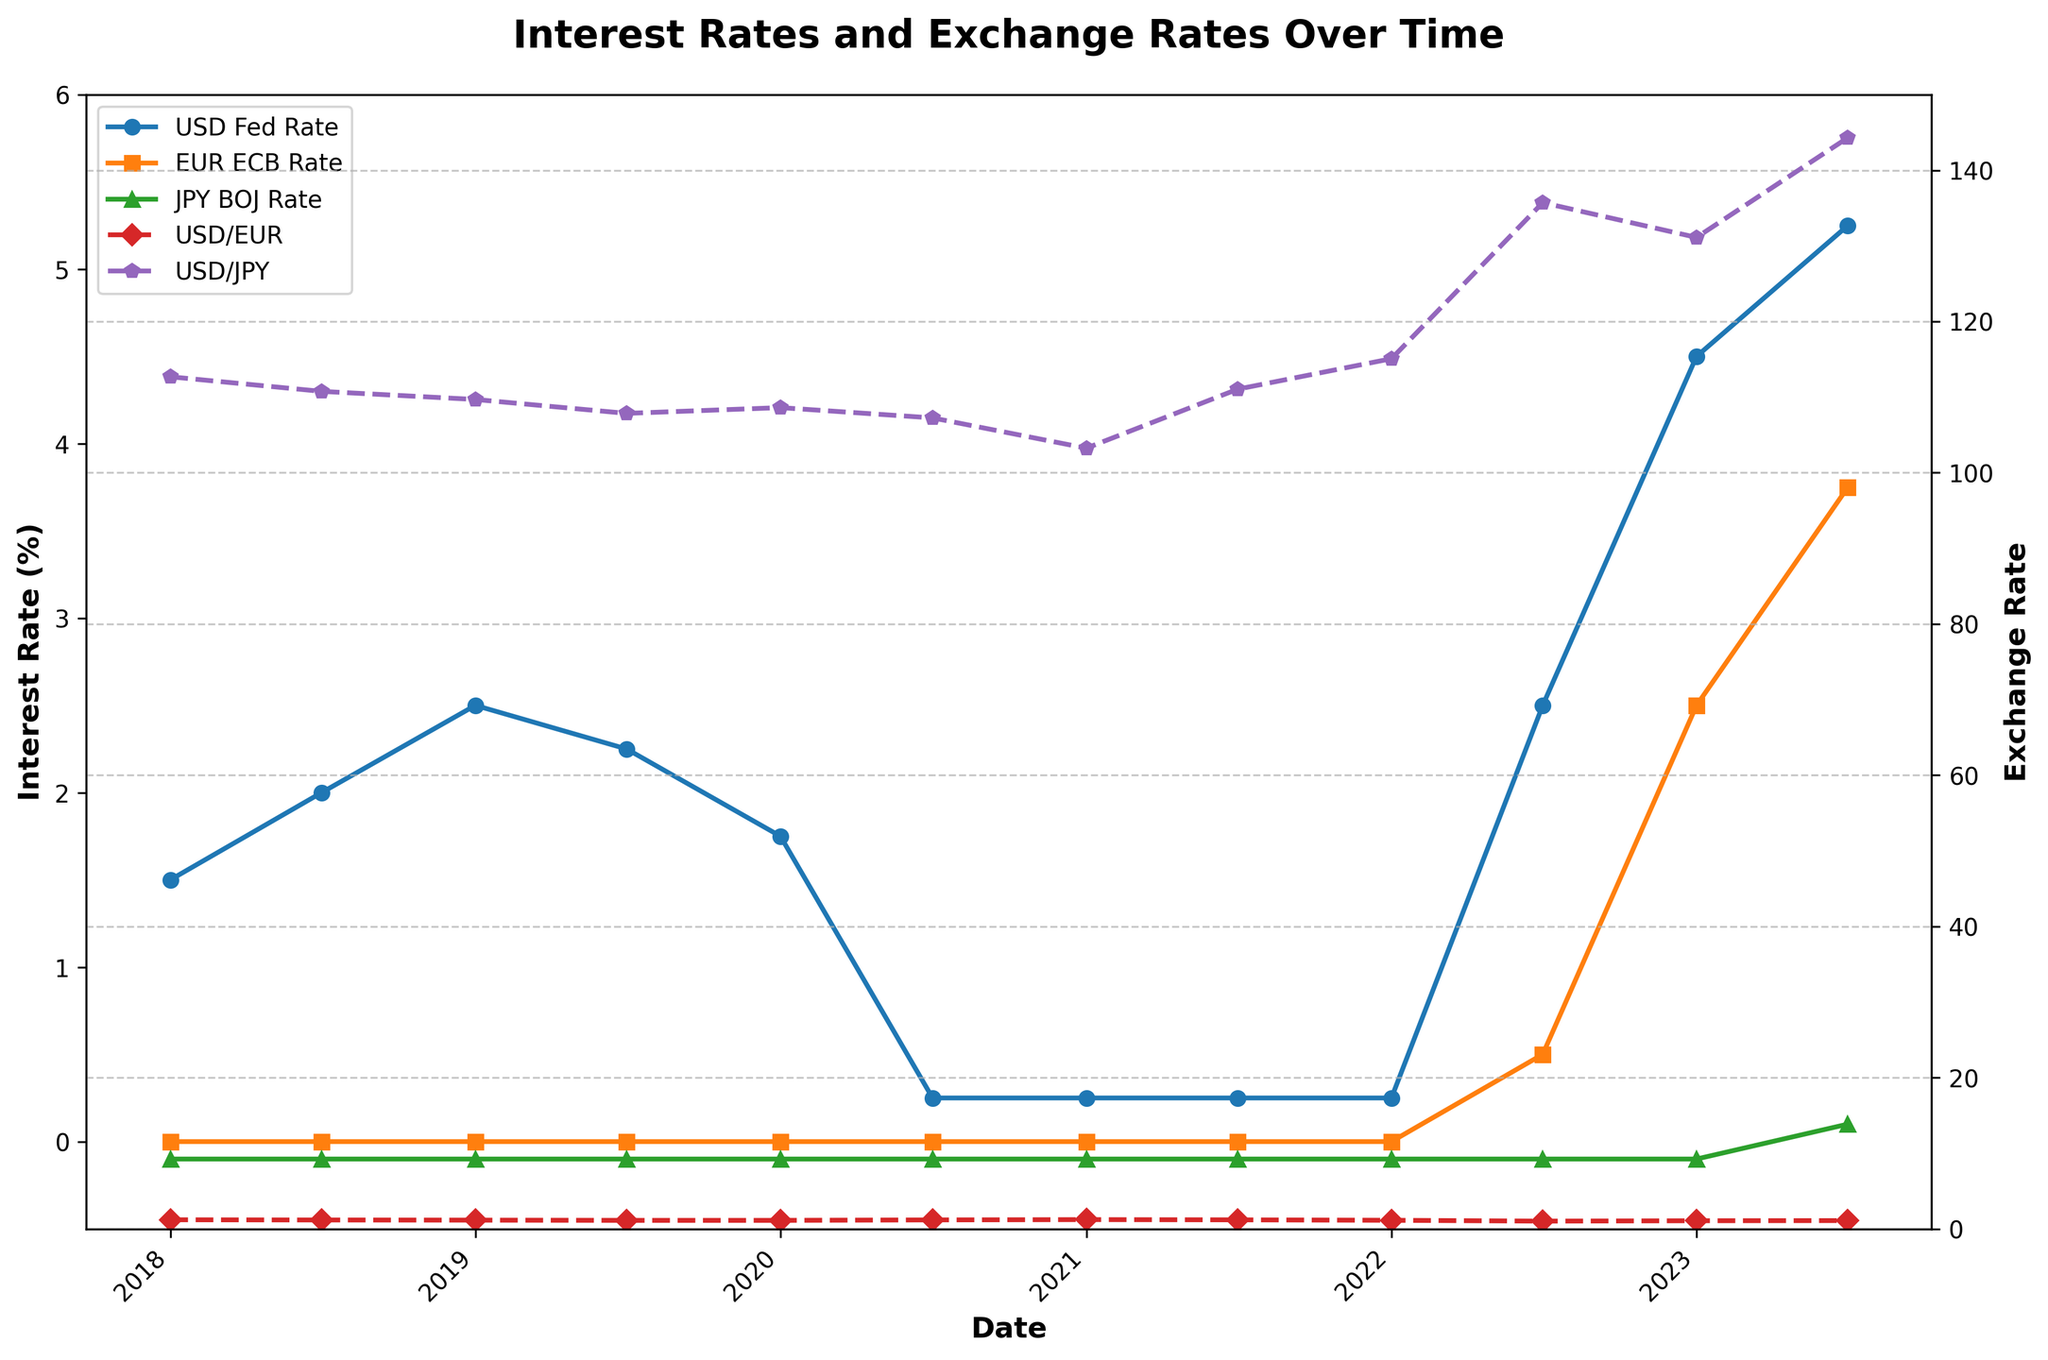Which currency pair has the most significant fluctuation in exchange rates? By looking at the chart showing the USD/EUR and USD/JPY exchange rates, the USD/JPY exchange rate has shown more significant changes compared to USD/EUR. For example, between 2022 and 2023, the fluctuation in the USD/JPY exchange rate is visibly more pronounced.
Answer: USD/JPY What was the interest rate set by the FED (USD) by mid-2023? Refer to the line representing the USD Fed Rate (in blue). By mid-2023, the interest rate was plotted at 5.25% on the chart.
Answer: 5.25% How did the ECB rate change between 2022-01-01 and 2022-07-01? To find this, look at the line for EUR ECB Rate (in orange). The ECB rate changed from 0.00% on 2022-01-01 to 0.50% on 2022-07-01.
Answer: 0.00% to 0.50% Which exchange rate showed an increase from 2022-01-01 to 2023-07-01? To determine this, observe the two lines representing USD/EUR and USD/JPY. From 2022-01-01 to 2023-07-01, the USD/JPY exchange rate increased, indicated by an upward trend, from approximately 115.08 to 144.31.
Answer: USD/JPY Between which dates did the USD/EUR exchange rate reach its lowest point? To identify the lowest point of the USD/EUR exchange rate, look for the lowest marker on the red line. The lowest point occurs around 2022-07-01 with an exchange rate of around 1.02.
Answer: Around 2022-07-01 What trend can be observed in the JPY BOJ Rate from 2020-07-01 to 2023-07-01? The green line representing the JPY BOJ Rate stays constant at -0.10 until it rises to 0.10 by 2023-07-01, indicating a flat trend followed by an increase.
Answer: Flat then increased Compare the highest USD Fed Rate with the highest EUR ECB Rate shown in the chart. By analyzing both blue (USD Fed Rate) and orange (EUR ECB Rate) lines, the highest USD Fed Rate is 5.25% (2023-07-01) and the highest EUR ECB Rate is 3.75% (2023-07-01). The USD Fed Rate is higher.
Answer: USD Fed Rate is higher Does the EUR ECB Rate tell anything about the stability of Eurozone interest rates between 2018 and 2021? By examining the orange line (EUR ECB Rate), it remains flat at 0.00% from 2018-2021, suggesting stability in Eurozone interest rates during this period.
Answer: Stability indicated What is the correlation between USD/JPY exchange rate and USD Fed Rate after 2021? Evaluate both the purple dashed line (USD/JPY) and the blue line (USD Fed Rate). A rise in the USD Fed Rate after 2021 coincides with a rise in USD/JPY, suggesting a positive correlation.
Answer: Positive correlation 